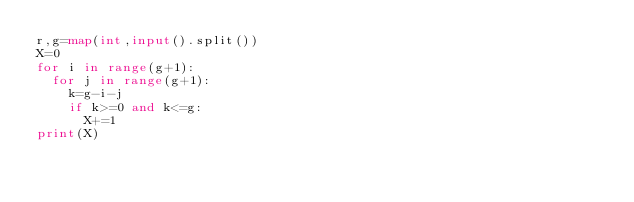<code> <loc_0><loc_0><loc_500><loc_500><_Python_>r,g=map(int,input().split())
X=0
for i in range(g+1):
  for j in range(g+1):
    k=g-i-j
    if k>=0 and k<=g:
      X+=1
print(X)
</code> 